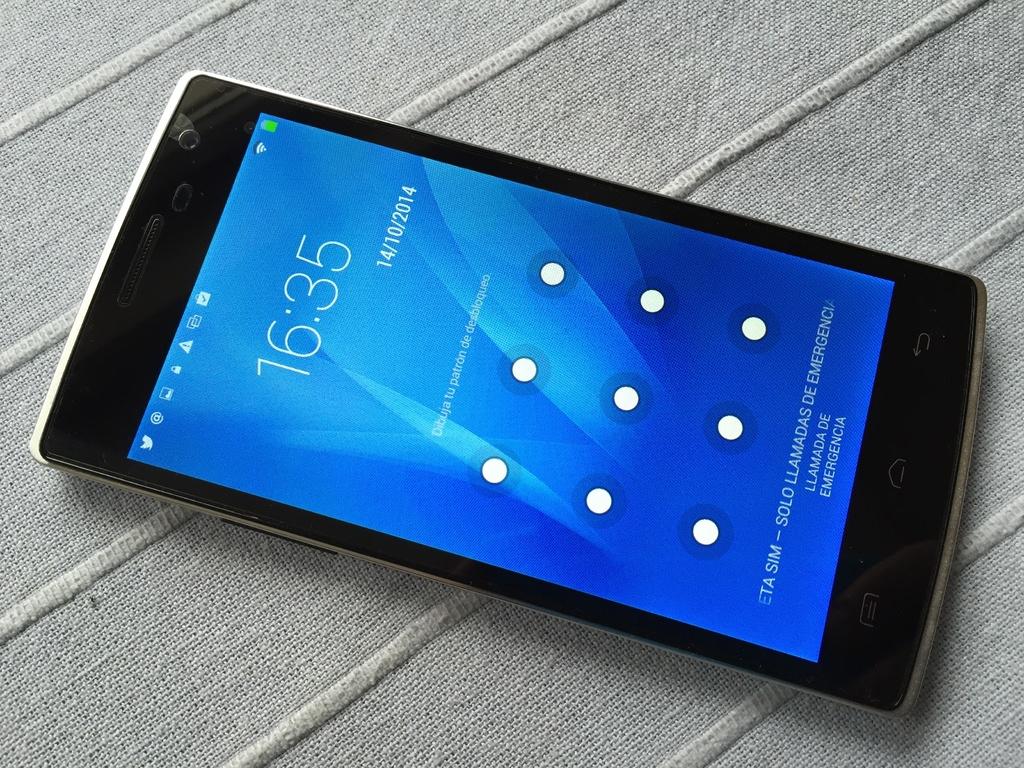What time is it?
Make the answer very short. 16:35. What's the date?
Provide a short and direct response. 14/10/2014. 